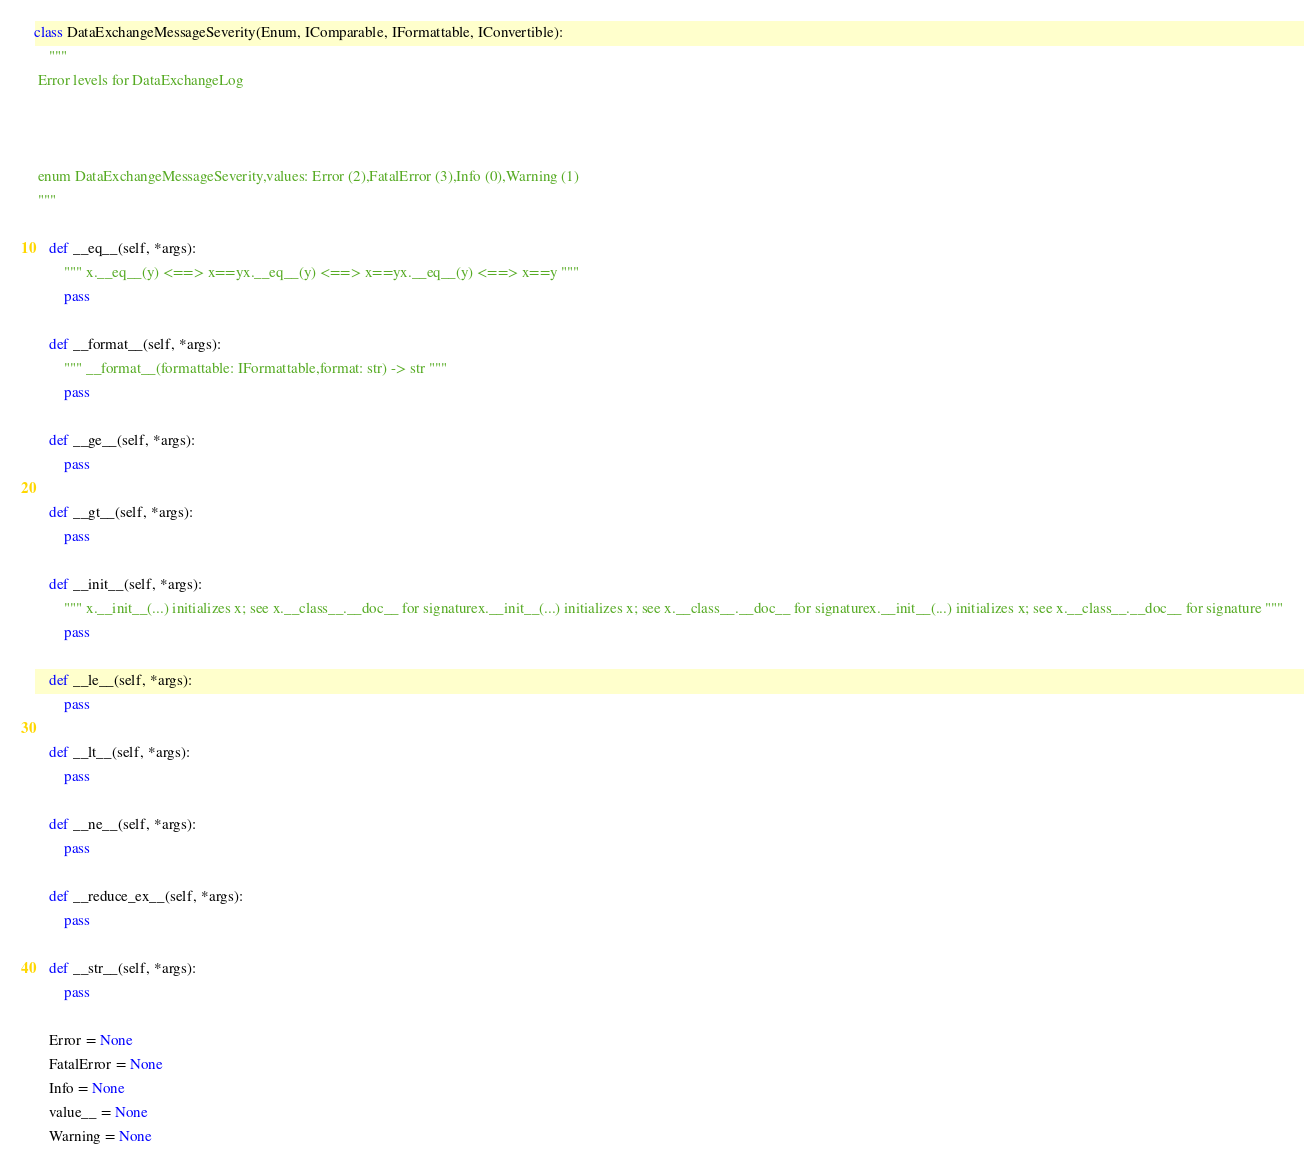<code> <loc_0><loc_0><loc_500><loc_500><_Python_>class DataExchangeMessageSeverity(Enum, IComparable, IFormattable, IConvertible):
    """
 Error levels for DataExchangeLog

 

 enum DataExchangeMessageSeverity,values: Error (2),FatalError (3),Info (0),Warning (1)
 """

    def __eq__(self, *args):
        """ x.__eq__(y) <==> x==yx.__eq__(y) <==> x==yx.__eq__(y) <==> x==y """
        pass

    def __format__(self, *args):
        """ __format__(formattable: IFormattable,format: str) -> str """
        pass

    def __ge__(self, *args):
        pass

    def __gt__(self, *args):
        pass

    def __init__(self, *args):
        """ x.__init__(...) initializes x; see x.__class__.__doc__ for signaturex.__init__(...) initializes x; see x.__class__.__doc__ for signaturex.__init__(...) initializes x; see x.__class__.__doc__ for signature """
        pass

    def __le__(self, *args):
        pass

    def __lt__(self, *args):
        pass

    def __ne__(self, *args):
        pass

    def __reduce_ex__(self, *args):
        pass

    def __str__(self, *args):
        pass

    Error = None
    FatalError = None
    Info = None
    value__ = None
    Warning = None
</code> 